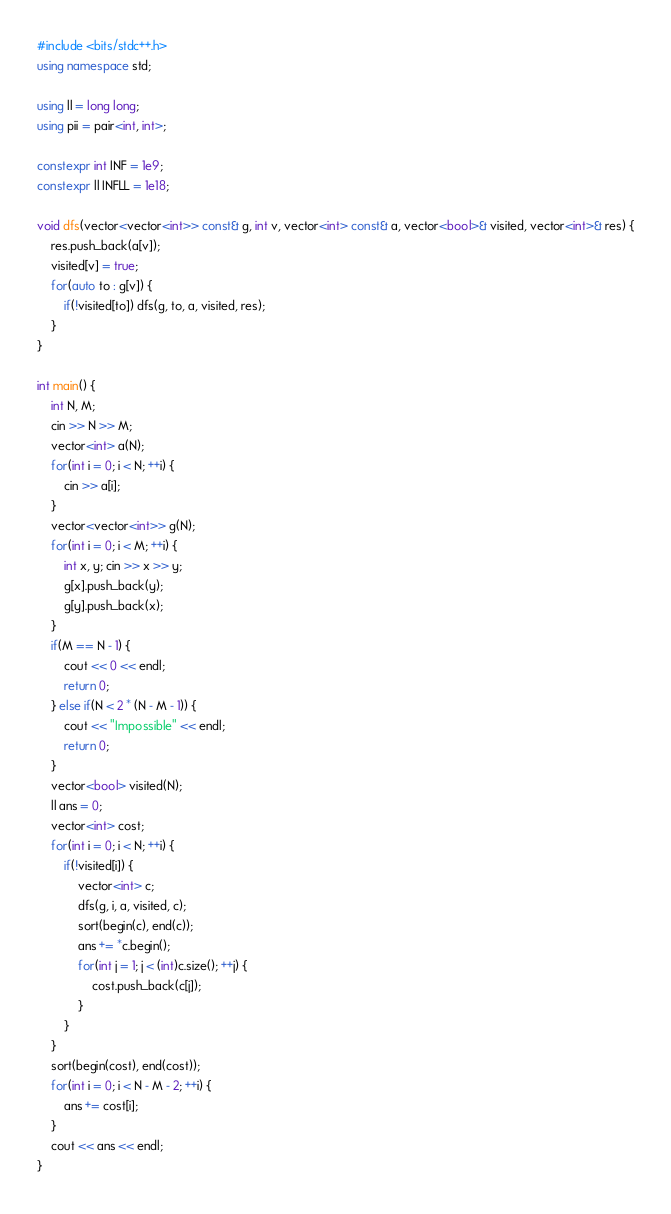Convert code to text. <code><loc_0><loc_0><loc_500><loc_500><_C++_>#include <bits/stdc++.h>
using namespace std;

using ll = long long;
using pii = pair<int, int>;

constexpr int INF = 1e9;
constexpr ll INFLL = 1e18;

void dfs(vector<vector<int>> const& g, int v, vector<int> const& a, vector<bool>& visited, vector<int>& res) {
    res.push_back(a[v]);
    visited[v] = true;
    for(auto to : g[v]) {
        if(!visited[to]) dfs(g, to, a, visited, res);
    }
}

int main() {
    int N, M;
    cin >> N >> M;
    vector<int> a(N);
    for(int i = 0; i < N; ++i) {
        cin >> a[i];
    }
    vector<vector<int>> g(N);
    for(int i = 0; i < M; ++i) {
        int x, y; cin >> x >> y;
        g[x].push_back(y);
        g[y].push_back(x);
    }
    if(M == N - 1) {
        cout << 0 << endl;
        return 0;
    } else if(N < 2 * (N - M - 1)) {
        cout << "Impossible" << endl;
        return 0;
    }
    vector<bool> visited(N);
    ll ans = 0;
    vector<int> cost;
    for(int i = 0; i < N; ++i) {
        if(!visited[i]) {
            vector<int> c;
            dfs(g, i, a, visited, c);
            sort(begin(c), end(c));
            ans += *c.begin();
            for(int j = 1; j < (int)c.size(); ++j) {
                cost.push_back(c[j]);
            }
        }
    }
    sort(begin(cost), end(cost));
    for(int i = 0; i < N - M - 2; ++i) {
        ans += cost[i];
    }
    cout << ans << endl;
}</code> 